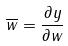Convert formula to latex. <formula><loc_0><loc_0><loc_500><loc_500>\overline { w } = \frac { \partial y } { \partial w }</formula> 